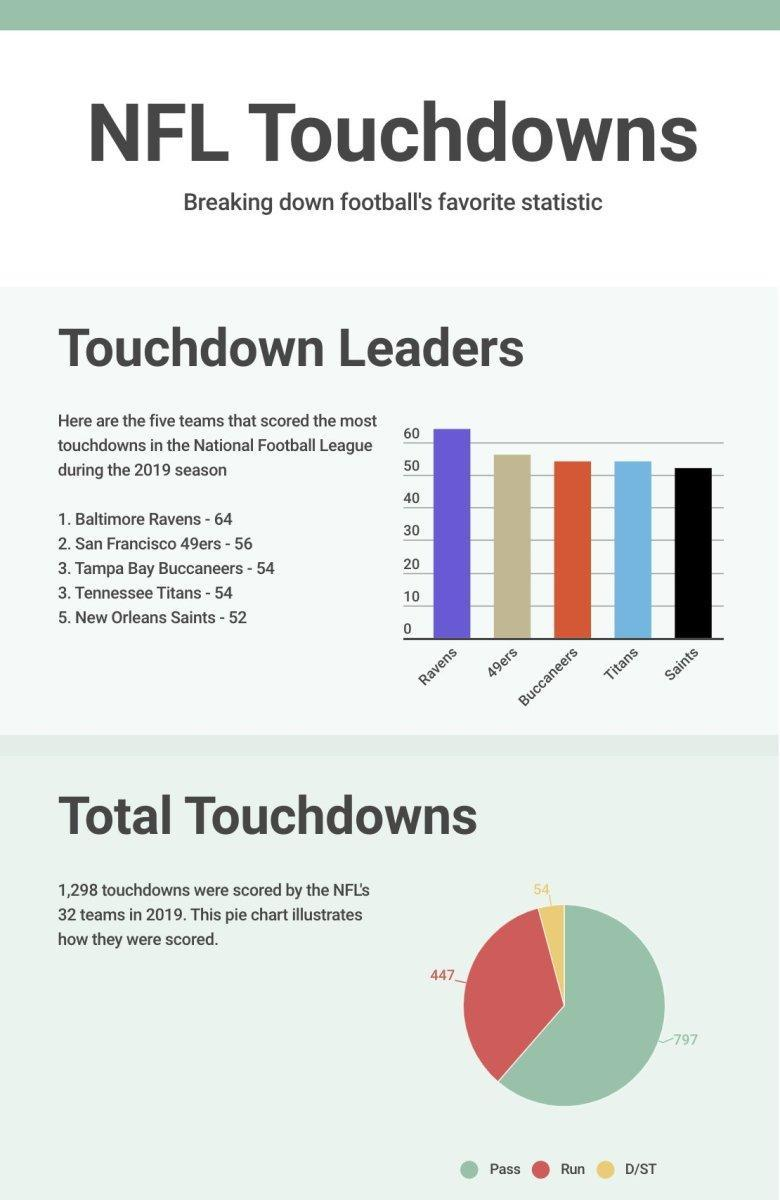What are the total runs scored by the NFL's 32 teams in 2019?
Answer the question with a short phrase. 447 What is the total number of passes by the NFL's 32 teams in 2019? 797 Which NFL team has scored the second-highest touchdowns during the 2019 season? San Francisco 49ers How many touchdowns were scored by Baltimore Ravens during the 2019 season? 64 